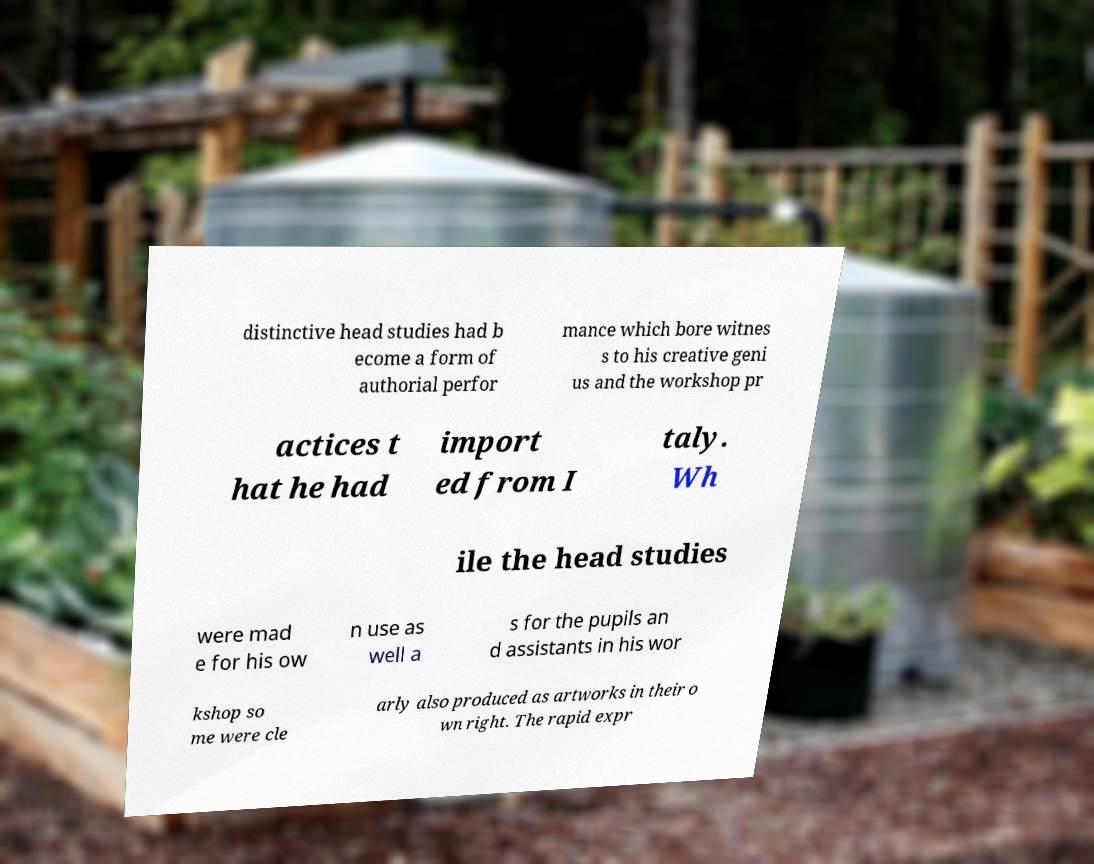What messages or text are displayed in this image? I need them in a readable, typed format. distinctive head studies had b ecome a form of authorial perfor mance which bore witnes s to his creative geni us and the workshop pr actices t hat he had import ed from I taly. Wh ile the head studies were mad e for his ow n use as well a s for the pupils an d assistants in his wor kshop so me were cle arly also produced as artworks in their o wn right. The rapid expr 